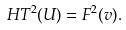<formula> <loc_0><loc_0><loc_500><loc_500>H T ^ { 2 } ( U ) = F ^ { 2 } ( v ) .</formula> 